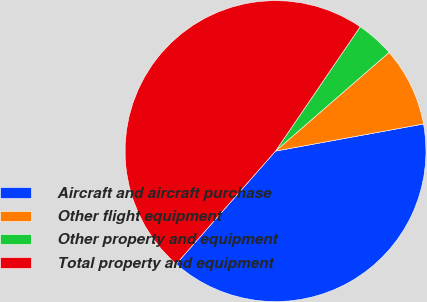Convert chart to OTSL. <chart><loc_0><loc_0><loc_500><loc_500><pie_chart><fcel>Aircraft and aircraft purchase<fcel>Other flight equipment<fcel>Other property and equipment<fcel>Total property and equipment<nl><fcel>39.36%<fcel>8.5%<fcel>4.1%<fcel>48.03%<nl></chart> 